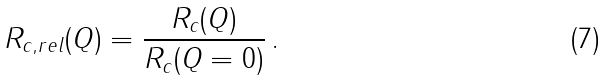<formula> <loc_0><loc_0><loc_500><loc_500>R _ { c , r e l } ( Q ) = \frac { R _ { c } ( Q ) } { R _ { c } ( Q = 0 ) } \, .</formula> 